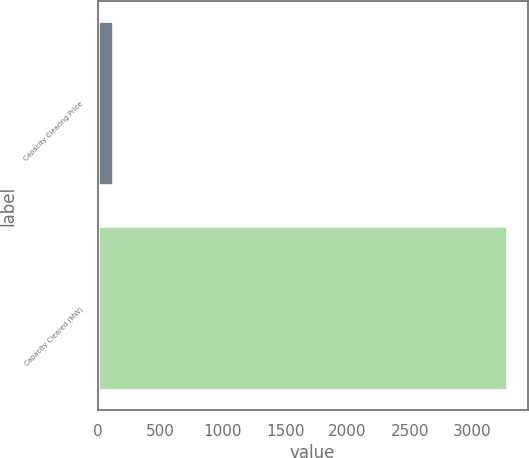Convert chart. <chart><loc_0><loc_0><loc_500><loc_500><bar_chart><fcel>Capacity Clearing Price<fcel>Capacity Cleared (MW)<nl><fcel>126<fcel>3277<nl></chart> 